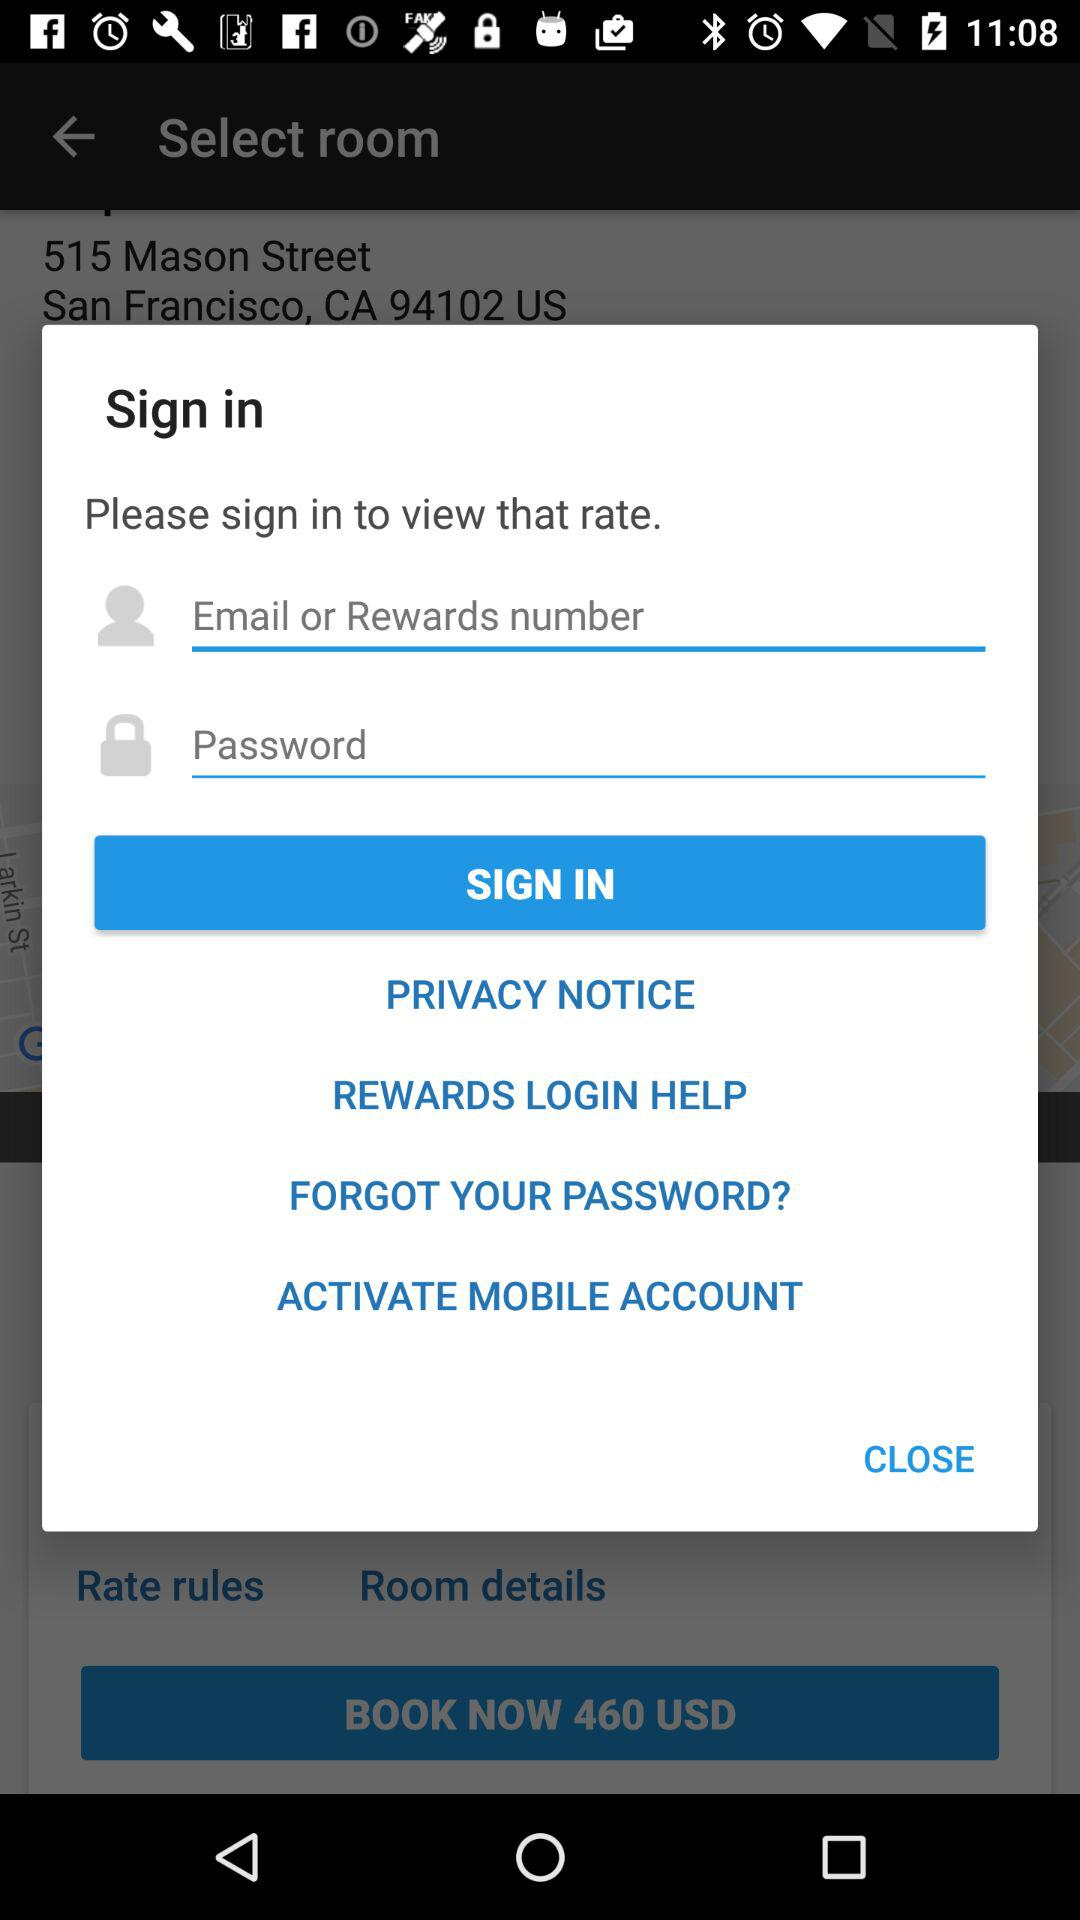What is the price to book the room? The price is 460 USD. 